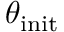Convert formula to latex. <formula><loc_0><loc_0><loc_500><loc_500>\theta _ { i n i t }</formula> 